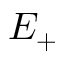Convert formula to latex. <formula><loc_0><loc_0><loc_500><loc_500>E _ { + }</formula> 